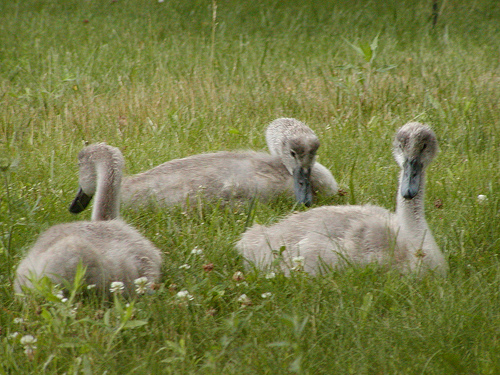<image>
Can you confirm if the duck is to the right of the duck? No. The duck is not to the right of the duck. The horizontal positioning shows a different relationship. Is the grass in the land? Yes. The grass is contained within or inside the land, showing a containment relationship. 